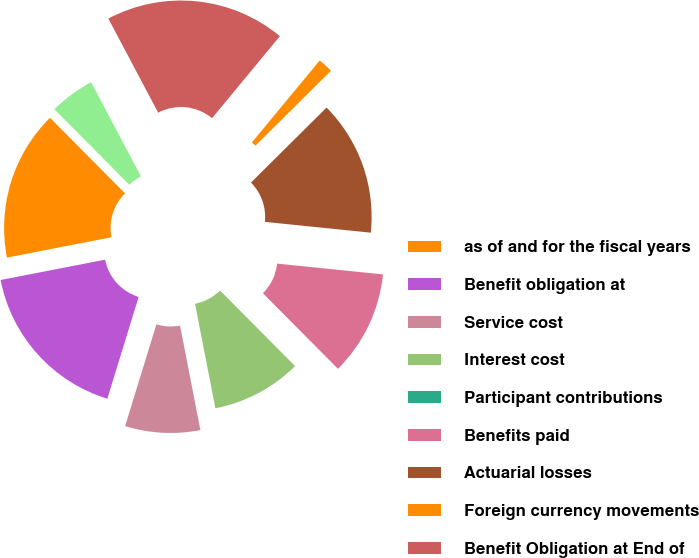<chart> <loc_0><loc_0><loc_500><loc_500><pie_chart><fcel>as of and for the fiscal years<fcel>Benefit obligation at<fcel>Service cost<fcel>Interest cost<fcel>Participant contributions<fcel>Benefits paid<fcel>Actuarial losses<fcel>Foreign currency movements<fcel>Benefit Obligation at End of<fcel>Fair value of plan assets at<nl><fcel>15.62%<fcel>17.19%<fcel>7.81%<fcel>9.38%<fcel>0.0%<fcel>10.94%<fcel>14.06%<fcel>1.56%<fcel>18.75%<fcel>4.69%<nl></chart> 